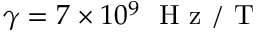Convert formula to latex. <formula><loc_0><loc_0><loc_500><loc_500>\gamma = 7 \times 1 0 ^ { 9 } H z / T</formula> 